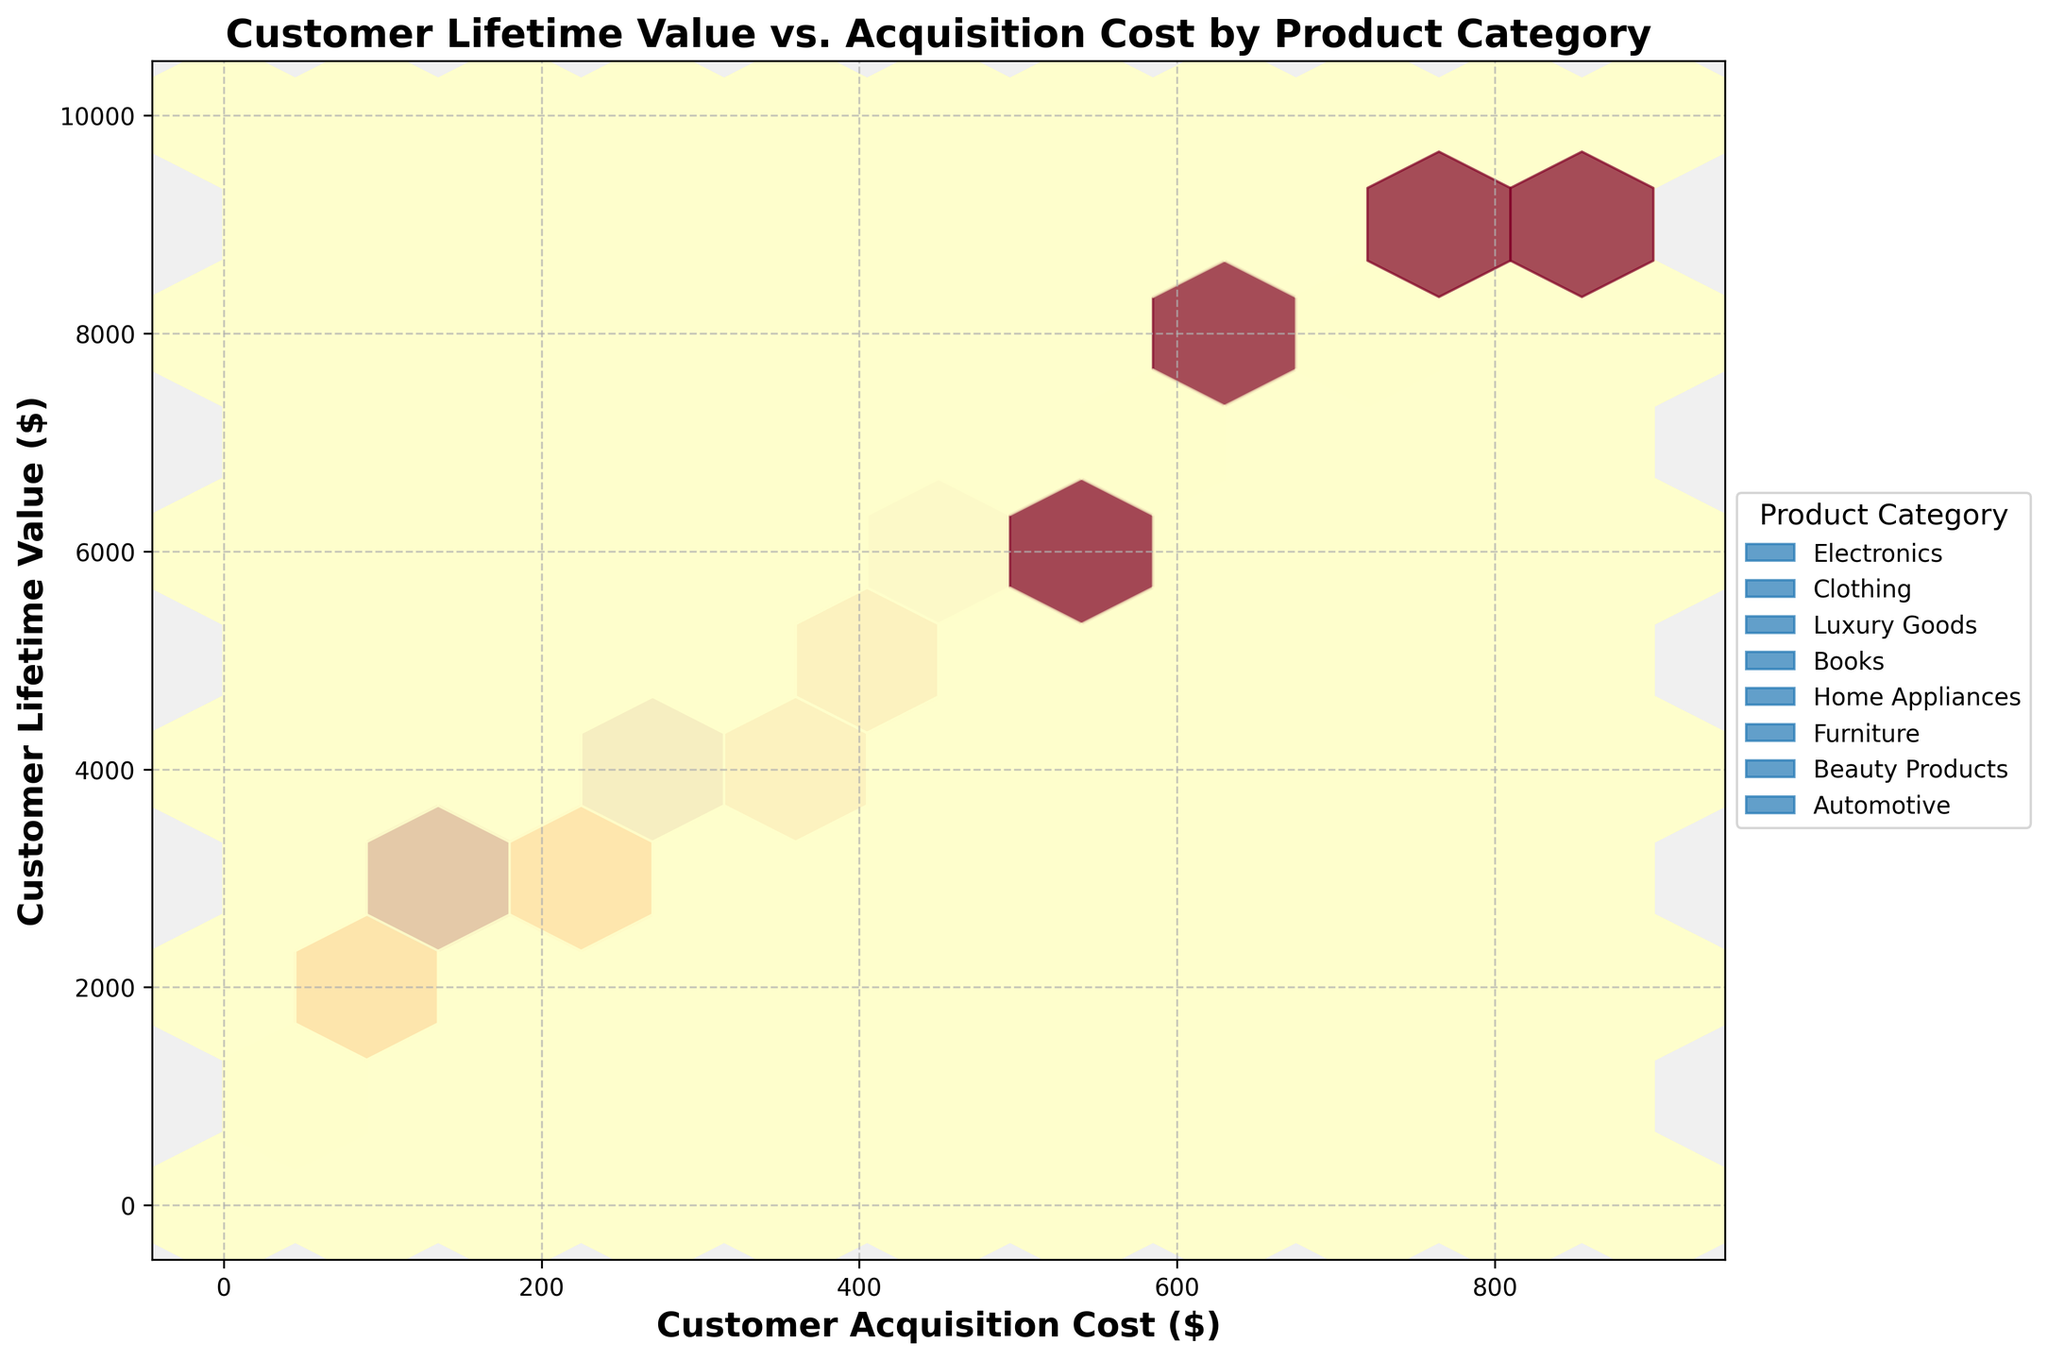What is the title of the figure? The title is clearly visible at the top of the figure, stating the overall subject of the plot.
Answer: Customer Lifetime Value vs. Acquisition Cost by Product Category What are the axes labels of the plot? The x-axis and y-axis labels describe the variables being compared in the plot.
Answer: Customer Acquisition Cost ($) and Customer Lifetime Value ($) Which product category had the highest customer lifetime value in the figure? By examining the figure, the Luxury Goods category appears to have the highest customer lifetime value, shown by the hexagons in the upper range of the y-axis.
Answer: Luxury Goods Do all product categories show a visible correlation between customer lifetime value and acquisition cost? Observing the hexbin densities within each category shows that most categories have an upward trend, indicating a correlation, but the strength may vary.
Answer: Yes How does the density of hexagons for Electronics compare to Luxury Goods? The hexagons' density represents the concentration of data points. Electronics have less dense hexagons, showing fewer high-value data points than Luxury Goods, which have more dense regions indicating many data points with both high acquisition cost and lifetime value.
Answer: Less dense Which product category appears to have the lowest acquisition costs with moderate lifetime values? Observing the plot regions with lower acquisition costs and moderate lifetime values reveals the Electronics and Books categories have these characteristics.
Answer: Electronics and Books Which product categories overlap in the figure? Based on the figure, distinct product categories might share the same region on the plot, indicating overlapping values for acquisition costs and lifetime values. The exact overlap can be noted among Electronics, Clothing, and Beauty Products.
Answer: Electronics, Clothing, Beauty Products How does the correlation between cost and value in Automotive compare to Books? The Automotive category shows a steeper and more pronounced upward trend in hexagons, whereas Books has a more modest incline, indicating a stronger correlation for Automotive.
Answer: Stronger in Automotive What is the range of customer acquisition costs for Home Appliances? By examining the extent of hexagons on the x-axis within this category, Home Appliances range from about $350 to $500 in customer acquisition costs.
Answer: $350 to $500 